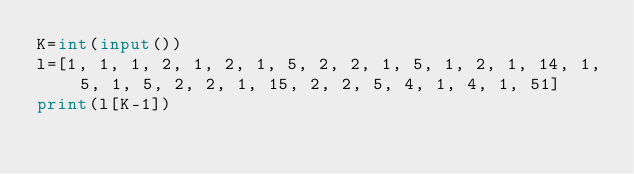<code> <loc_0><loc_0><loc_500><loc_500><_Python_>K=int(input())
l=[1, 1, 1, 2, 1, 2, 1, 5, 2, 2, 1, 5, 1, 2, 1, 14, 1, 5, 1, 5, 2, 2, 1, 15, 2, 2, 5, 4, 1, 4, 1, 51]
print(l[K-1])</code> 